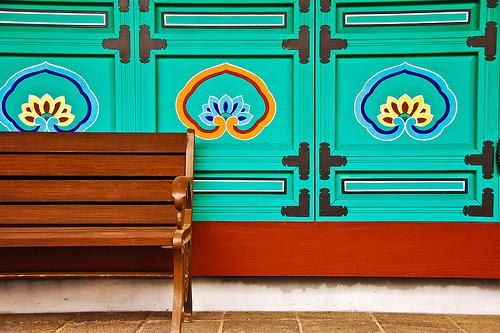Question: what flower is painted on the walls?
Choices:
A. Lotus.
B. Dandelion.
C. Tulip.
D. Carnation.
Answer with the letter. Answer: A Question: how many flowers are painted?
Choices:
A. 2.
B. 1.
C. 3.
D. 4.
Answer with the letter. Answer: C Question: what color is the wall?
Choices:
A. Teal.
B. White.
C. Yellow.
D. Brown.
Answer with the letter. Answer: A Question: where is the lotus flower?
Choices:
A. In the vase.
B. In the garden.
C. On the table.
D. On the wall.
Answer with the letter. Answer: D Question: what is the ground made of?
Choices:
A. Grass.
B. Wood.
C. Vinyl.
D. Stone.
Answer with the letter. Answer: D Question: where was this photo taken?
Choices:
A. On the sidewalk.
B. In the waiting area.
C. At a car park.
D. At a repair shop.
Answer with the letter. Answer: B 